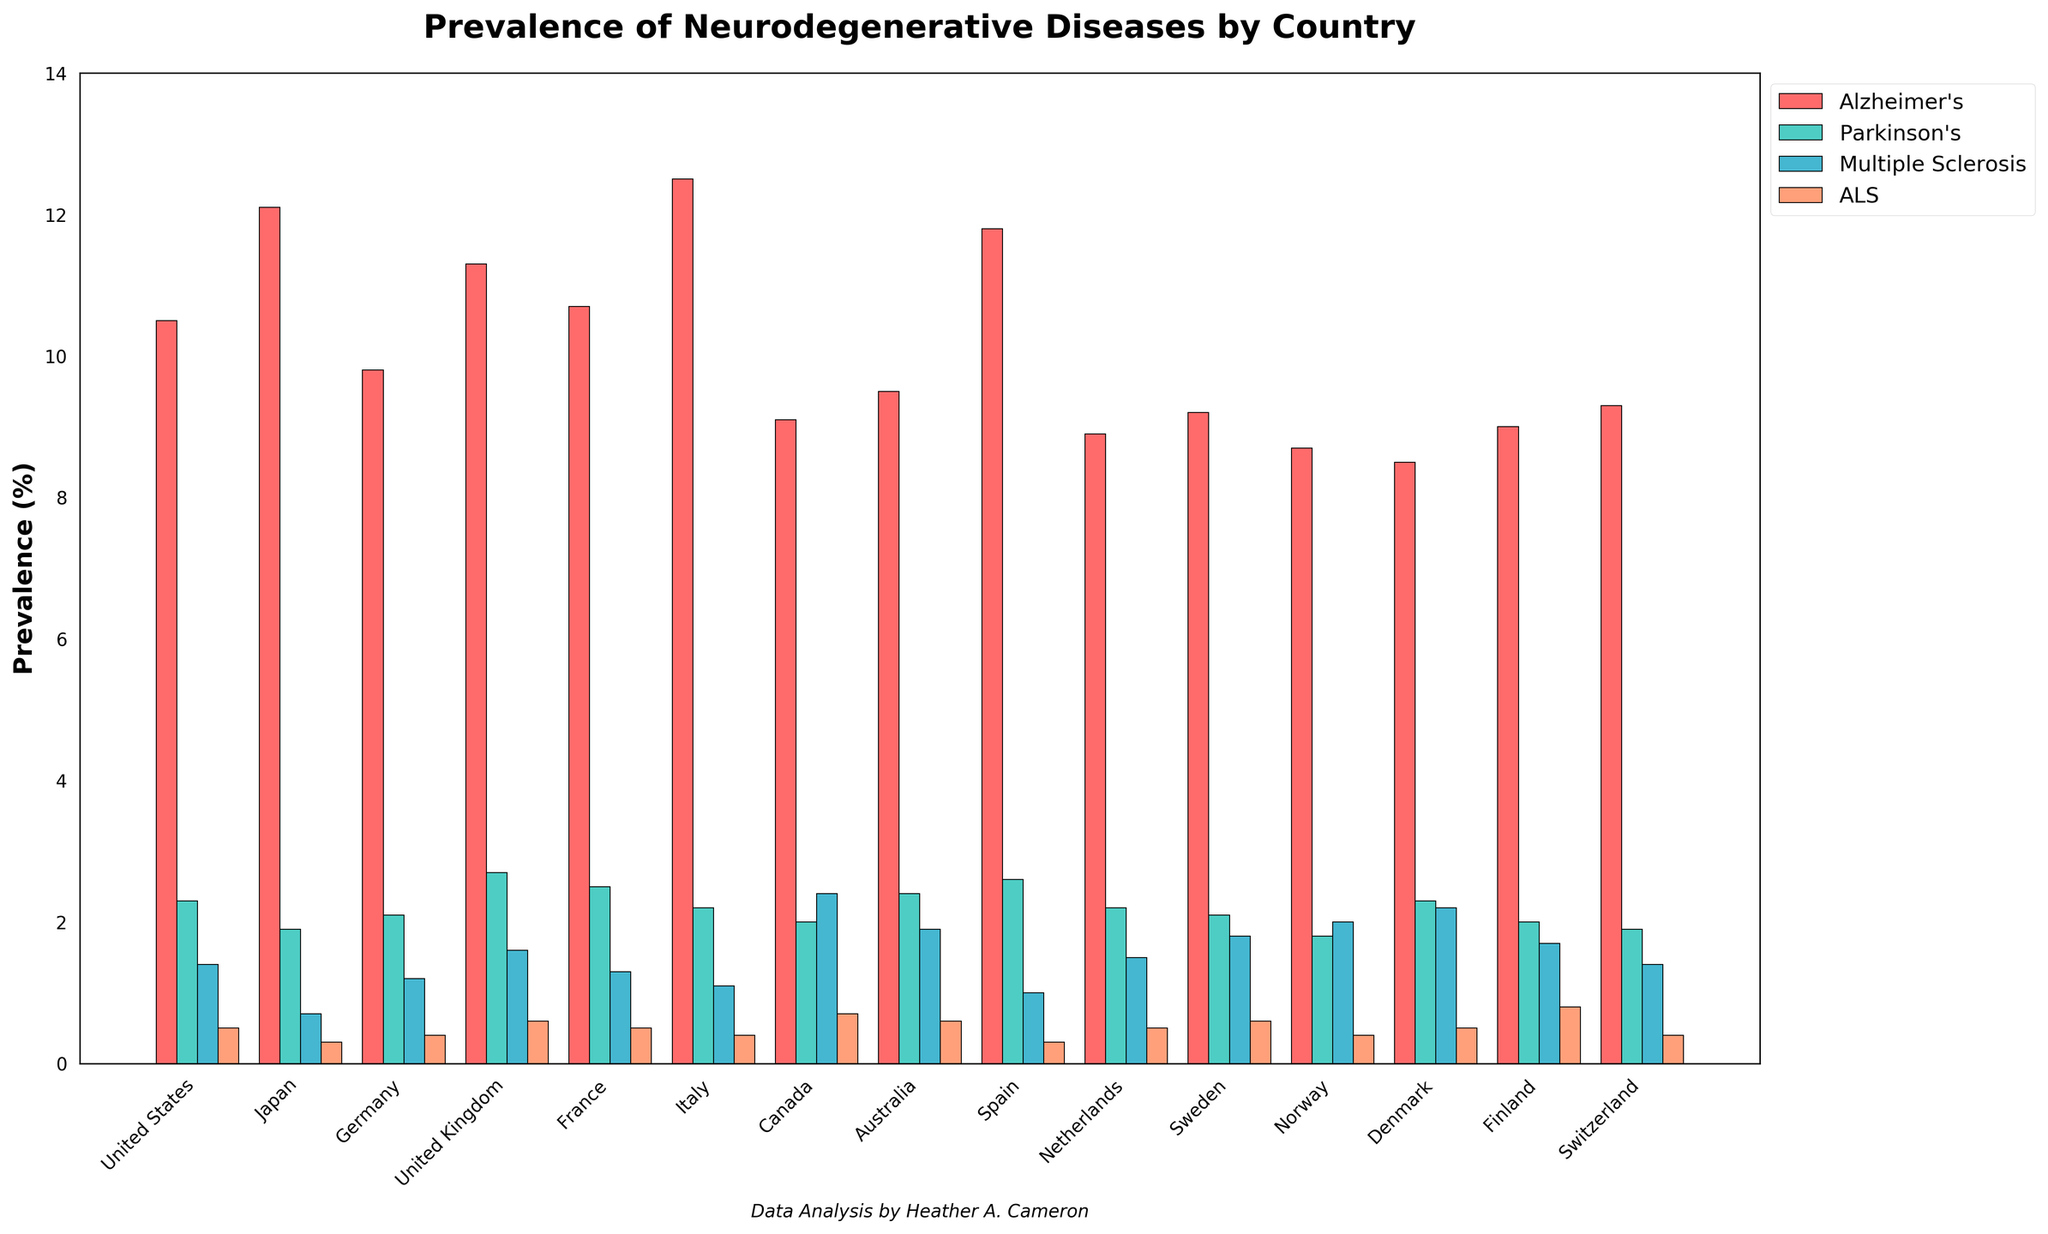Which country has the highest prevalence of Alzheimer's disease? By visually inspecting the bar heights, the tallest bar in the Alzheimer's category is the one for Italy.
Answer: Italy Between the United States and France, which country has a higher prevalence of Parkinson's disease? By comparing the height of the bars for the Parkinson's disease category for the United States and France, France has a higher bar.
Answer: France Which country has the lowest prevalence of ALS? By comparing the bars for ALS across all countries, the shortest bars are tied between Japan and Spain. Finland has the lowest prevalence of 0.3%.
Answer: Japan, Spain What is the total prevalence of neurodegenerative diseases in Canada? Adding the prevalence percentages for Canada across all diseases: 9.1 (Alzheimer's) + 2.0 (Parkinson's) + 2.4 (Multiple Sclerosis) + 0.7 (ALS) = 14.2
Answer: 14.2 Which country has a higher combined prevalence of Multiple Sclerosis and ALS, Norway or Sweden? For Norway, Multiple Sclerosis is 2.0 and ALS is 0.4, totaling 2.4. For Sweden, Multiple Sclerosis is 1.8 and ALS is 0.6, totaling 2.4. Both countries have an equal combined prevalence of 2.4% for these diseases.
Answer: Both equal Which country has the highest average prevalence of all four neurodegenerative diseases? To find the average, we sum the values for each country and divide by 4. The country with the highest average value is Japan: (12.1 + 1.9 + 0.7 + 0.3) / 4 = 3.75.
Answer: Japan Compare the prevalence of Alzheimer's disease in Italy and Germany. Which one is higher and by how much? Italy has a prevalence of 12.5, while Germany has 9.8. The difference is 12.5 - 9.8 = 2.7. Italy has a higher prevalence by 2.7.
Answer: Italy, 2.7 Which disease has the most uniform distribution across the countries in terms of prevalence? Visually inspecting the bar heights for uniformity, ALS has the most similar bar heights across all countries, indicating a more uniform distribution.
Answer: ALS What is the difference in prevalence of Multiple Sclerosis between Finland and Switzerland? The bar height for Multiple Sclerosis in Finland is 1.7 and in Switzerland is 1.4. The difference is 1.7 - 1.4 = 0.3.
Answer: 0.3 Which country has the biggest difference in prevalence between Alzheimer's and Parkinson's diseases? For each country, subtract the prevalence of Parkinson's from Alzheimer's. Italy has the highest difference: 12.5 (Alzheimer's) - 2.2 (Parkinson's) = 10.3.
Answer: Italy 